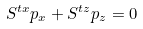<formula> <loc_0><loc_0><loc_500><loc_500>S ^ { t x } p _ { x } + S ^ { t z } p _ { z } = 0</formula> 